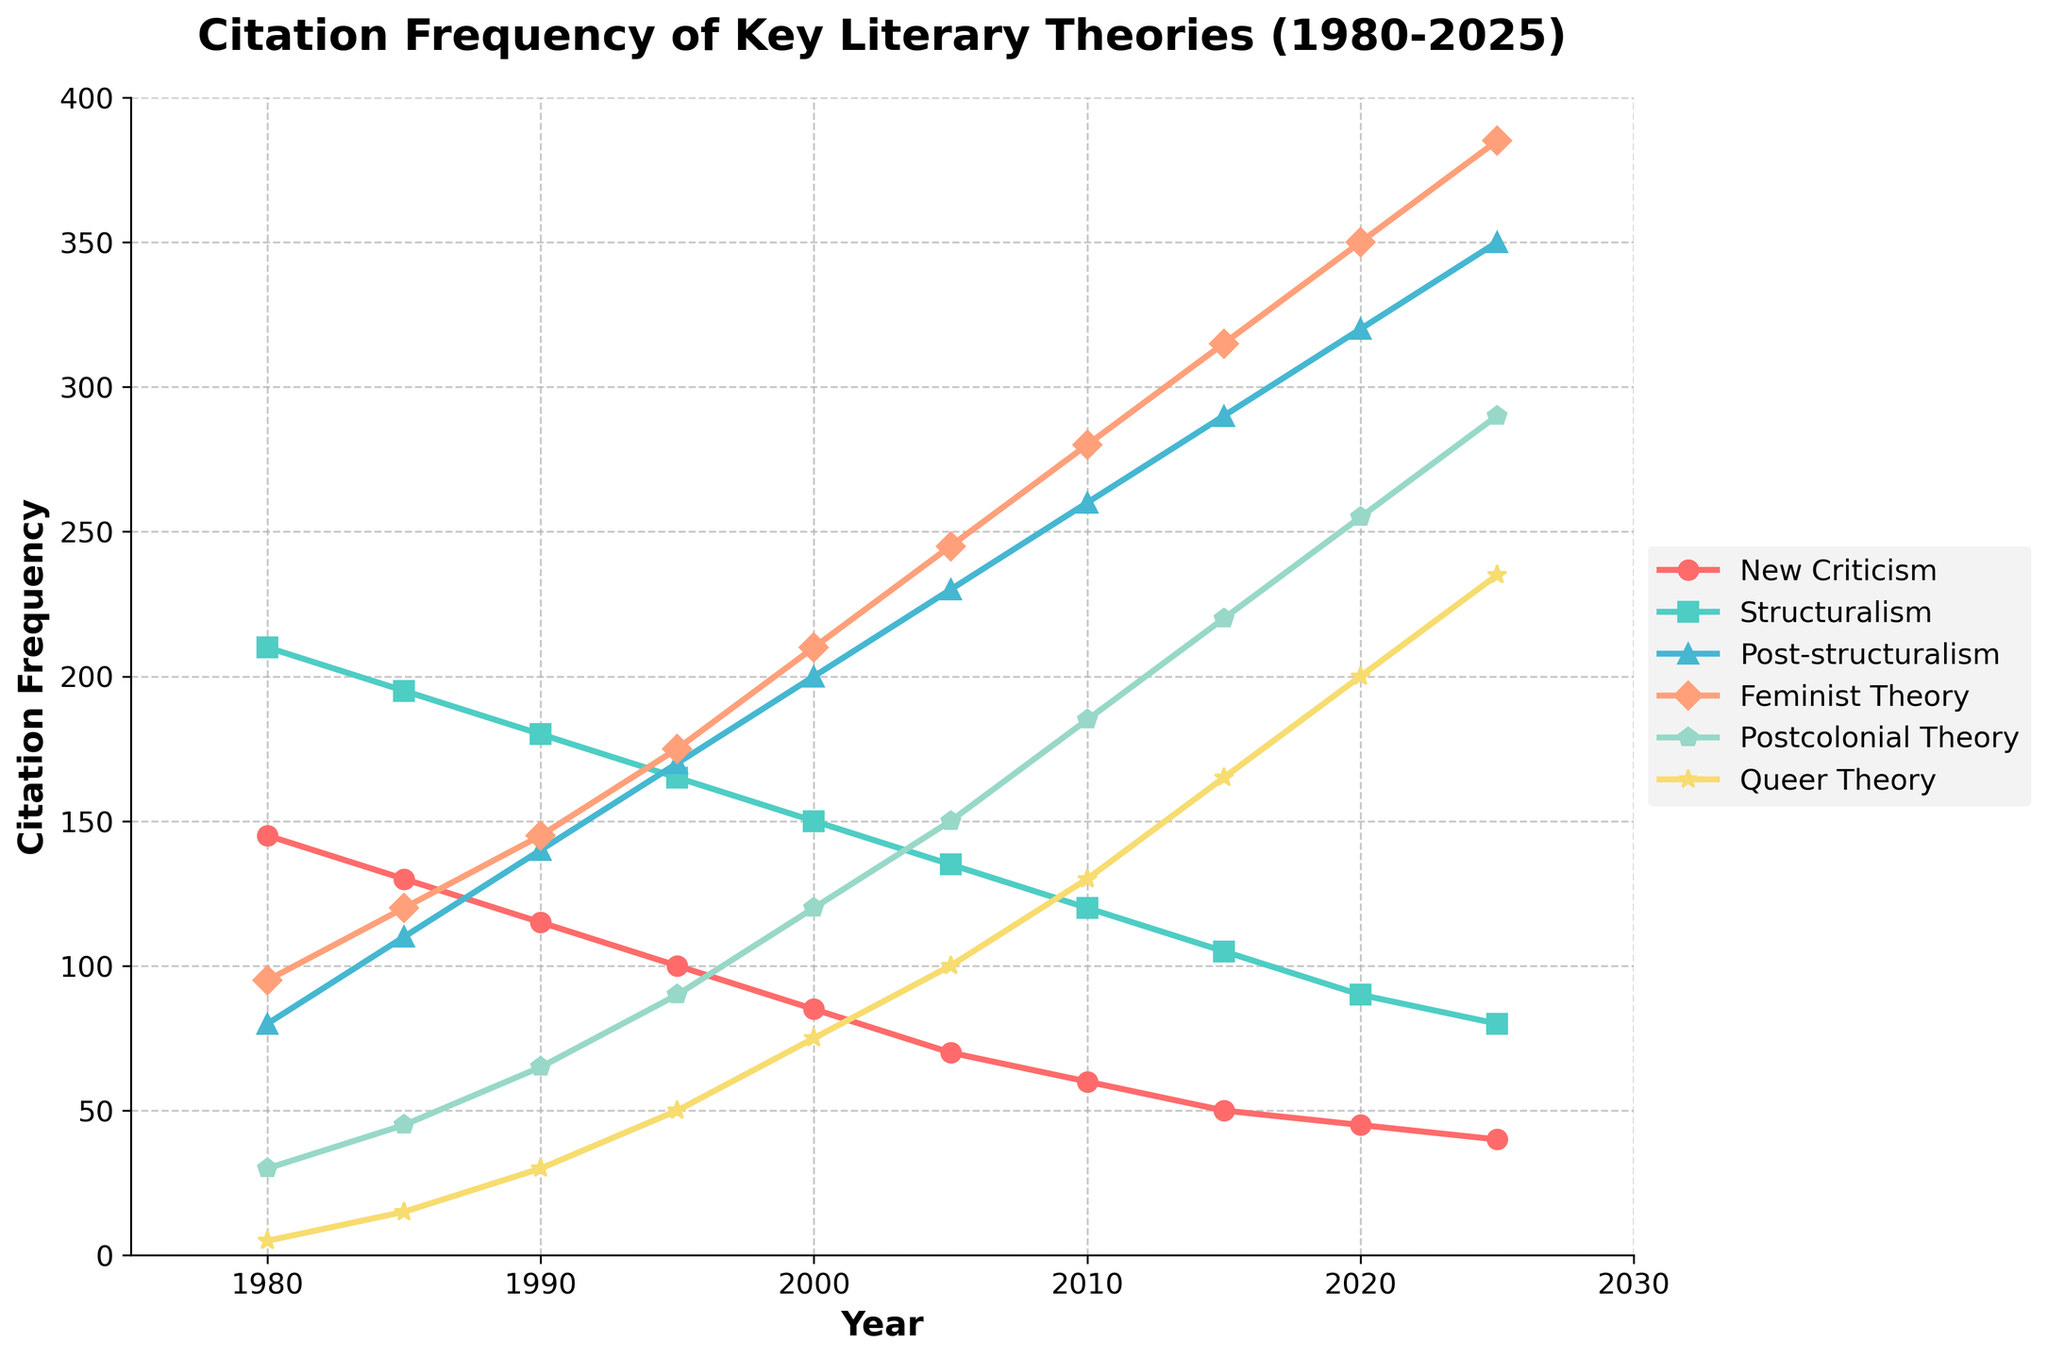Which theory had the highest citation frequency in 2020? To find the answer, look at the citation frequency for each theory in the year 2020. The data reveals the following citations: New Criticism 45, Structuralism 90, Post-structuralism 320, Feminist Theory 350, Postcolonial Theory 255, Queer Theory 200. Among these, Feminist Theory has the highest citation frequency.
Answer: Feminist Theory In what year did Queer Theory citations first exceed 100? To answer this, find the citation frequencies for Queer Theory across all years and identify the first year the frequency exceeds 100. From the data, the citation frequencies for Queer Theory are as follows: 1980 (5), 1985 (15), 1990 (30), 1995 (50), 2000 (75), 2005 (100), 2010 (130). The first year it exceeds 100 is 2010.
Answer: 2010 Compare the citation trends of New Criticism and Post-structuralism between 1980 and 2025. Which theory shows a decrease, and which shows an increase? Examine the citation frequencies for both theories from 1980 to 2025. New Criticism citations are: 1980 (145), 1985 (130), 1990 (115), 1995 (100), 2000 (85), 2005 (70), 2010 (60), 2015 (50), 2020 (45), 2025 (40). Post-structuralism citations are: 1980 (80), 1985 (110), 1990 (140), 1995 (170), 2000 (200), 2005 (230), 2010 (260), 2015 (290), 2020 (320), 2025 (350). New Criticism shows a decrease, while Post-structuralism displays an increase.
Answer: New Criticism decreases, Post-structuralism increases Which theory had the least citation frequency in 1990? To determine this, check the citation frequencies for all theories in 1990: New Criticism 115, Structuralism 180, Post-structuralism 140, Feminist Theory 145, Postcolonial Theory 65, and Queer Theory 30. Queer Theory has the least citation frequency.
Answer: Queer Theory Calculate the average citation frequency of Structuralism from 1980 to 2025. Add the citation frequencies for Structuralism across these years: (1980: 210 + 1985: 195 + 1990: 180 + 1995: 165 + 2000: 150 + 2005: 135 + 2010: 120 + 2015: 105 + 2020: 90 + 2025: 80). Sum = 1430. Number of years = 10. The average is 1430 / 10 = 143.
Answer: 143 Identify the theory with the fastest-growing citation trend between 1980 and 2025. Look for the theory with the steepest increase in citation frequencies over time. Calculate differences from 1980 to 2025: New Criticism (-105), Structuralism (-130), Post-structuralism (+270), Feminist Theory (+290), Postcolonial Theory (+260), Queer Theory (+230). Feminist Theory has the steepest increase.
Answer: Feminist Theory Which two theories had the closest citation frequencies in the year 2015? Check the citation frequencies for each theory in 2015: New Criticism 50, Structuralism 105, Post-structuralism 290, Feminist Theory 315, Postcolonial Theory 220, Queer Theory 165. The closest values are Structuralism (105) and New Criticism (50) with a difference of 55.
Answer: New Criticism and Structuralism 